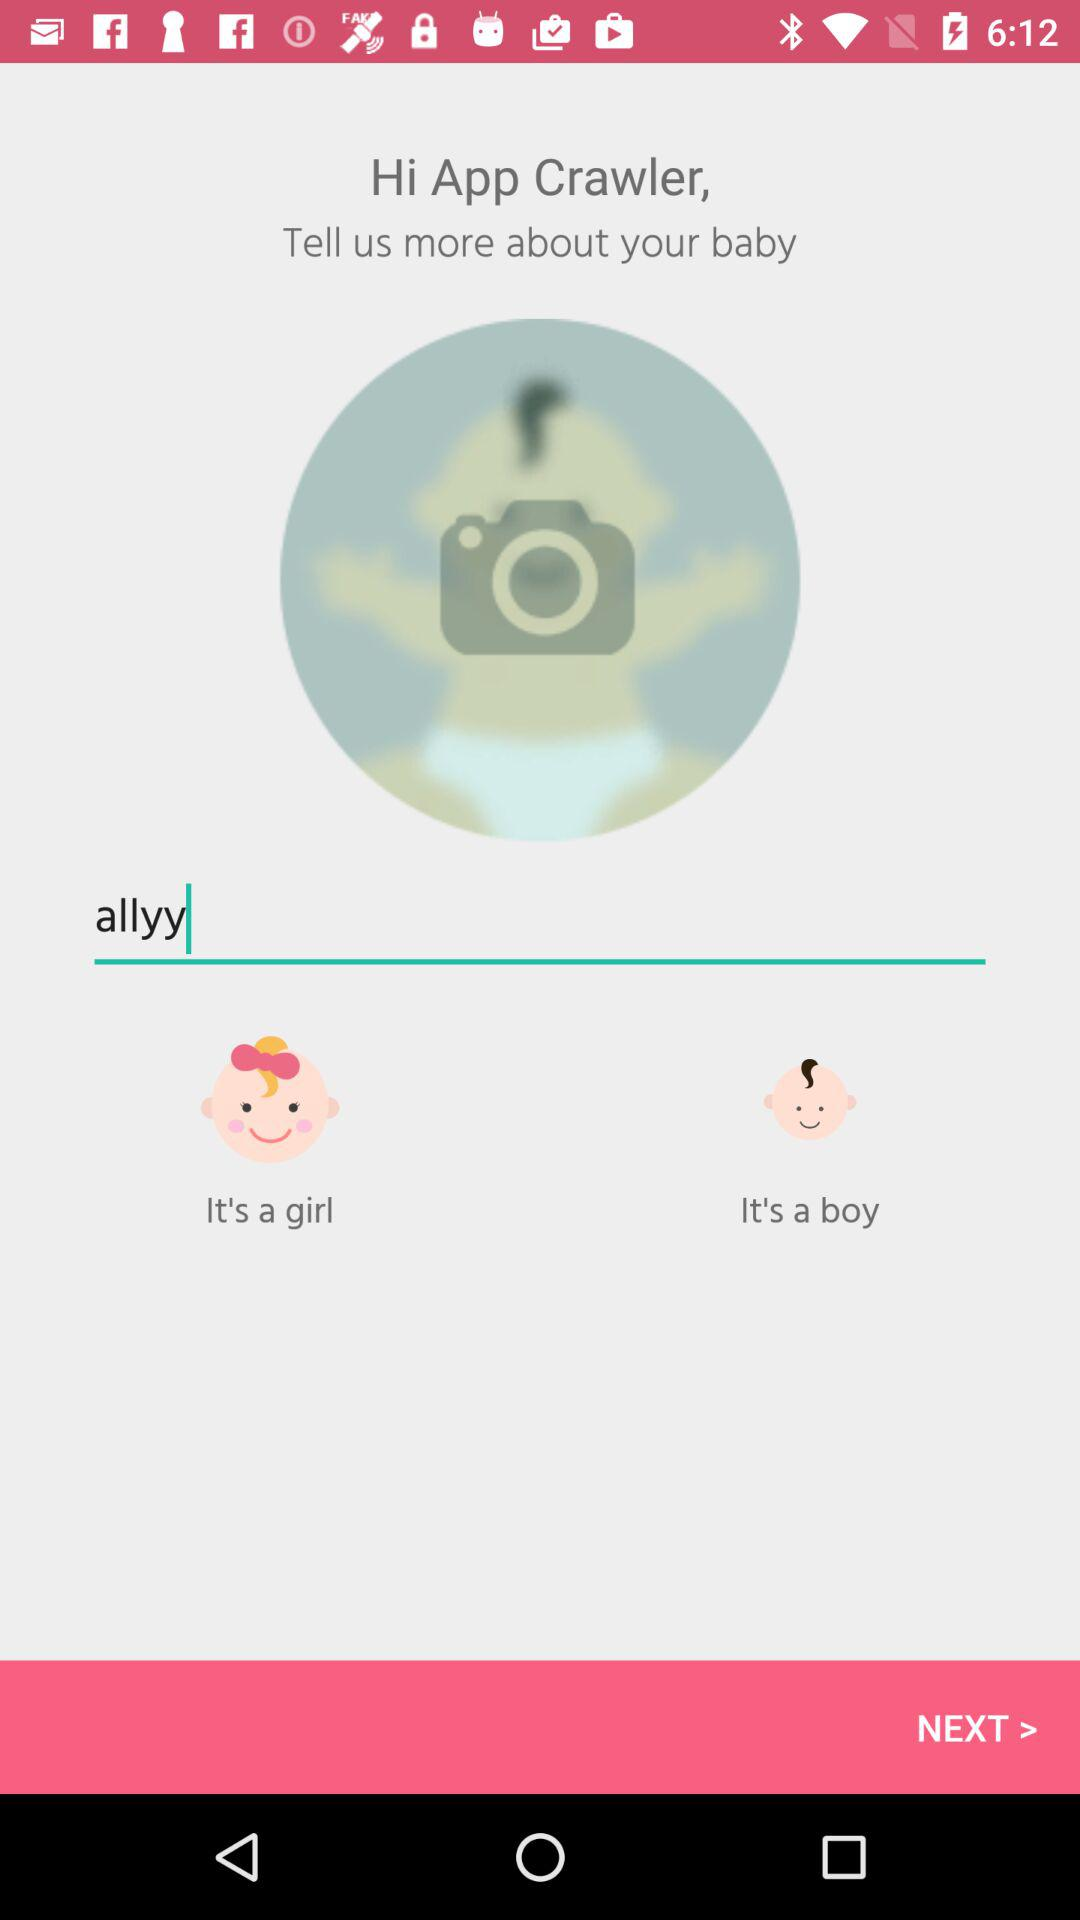What is the name of the baby? The name of the baby is Allyy. 